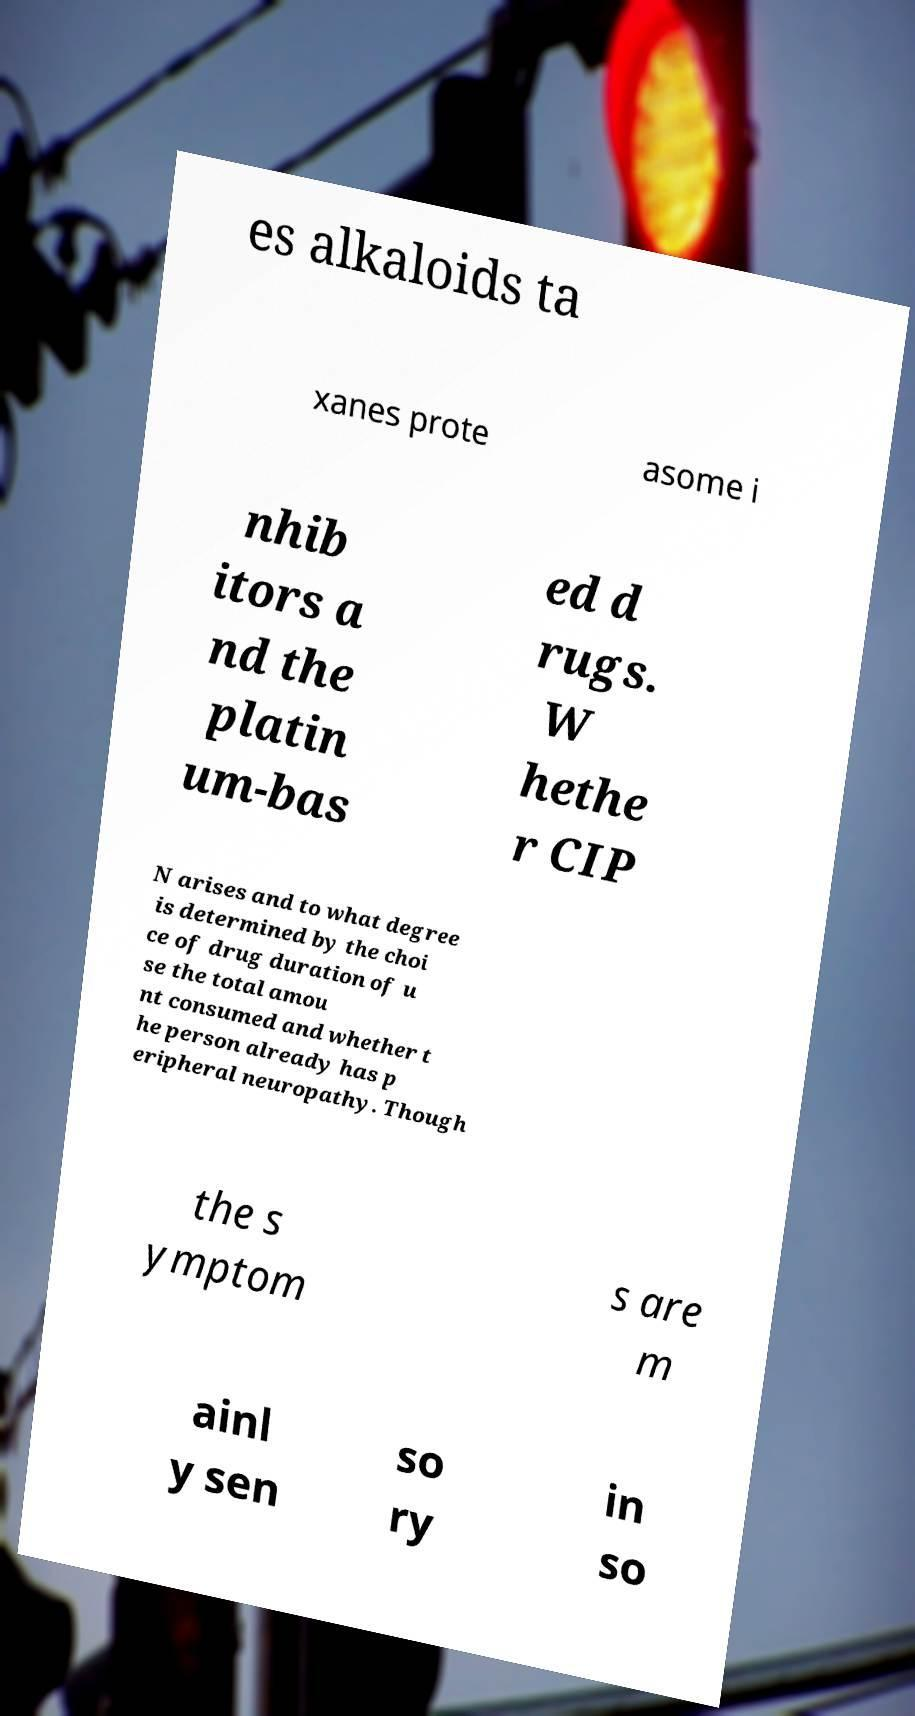Could you extract and type out the text from this image? es alkaloids ta xanes prote asome i nhib itors a nd the platin um-bas ed d rugs. W hethe r CIP N arises and to what degree is determined by the choi ce of drug duration of u se the total amou nt consumed and whether t he person already has p eripheral neuropathy. Though the s ymptom s are m ainl y sen so ry in so 